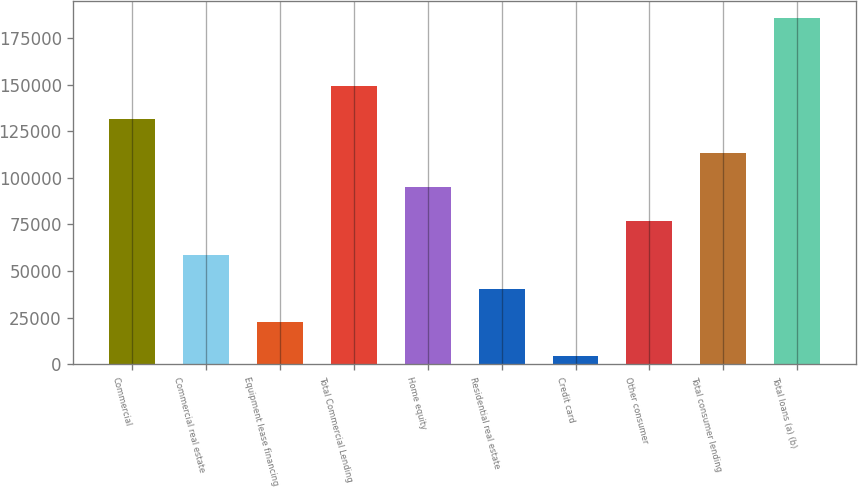Convert chart. <chart><loc_0><loc_0><loc_500><loc_500><bar_chart><fcel>Commercial<fcel>Commercial real estate<fcel>Equipment lease financing<fcel>Total Commercial Lending<fcel>Home equity<fcel>Residential real estate<fcel>Credit card<fcel>Other consumer<fcel>Total consumer lending<fcel>Total loans (a) (b)<nl><fcel>131390<fcel>58768.9<fcel>22458.3<fcel>149545<fcel>95079.5<fcel>40613.6<fcel>4303<fcel>76924.2<fcel>113235<fcel>185856<nl></chart> 